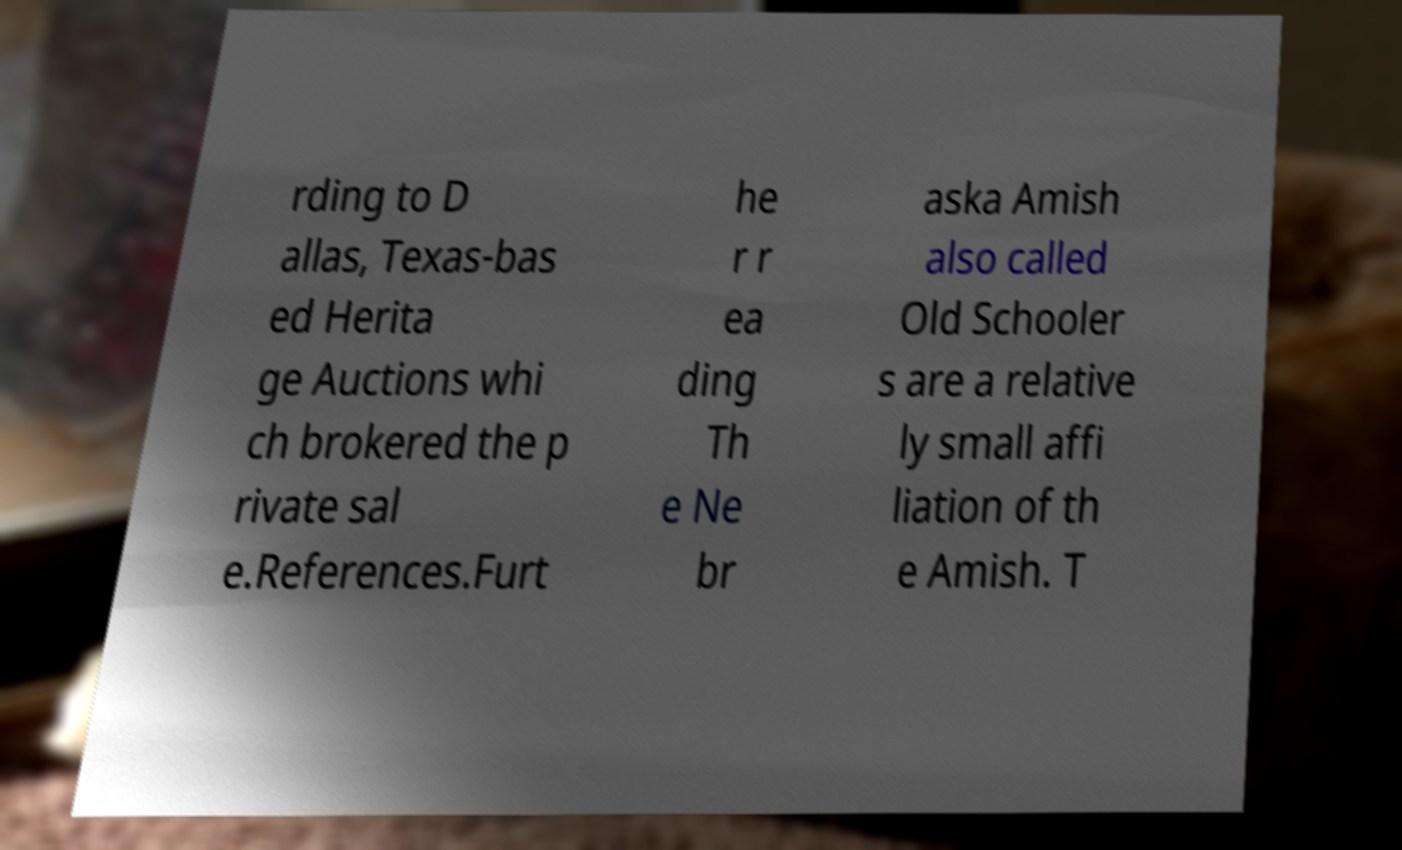There's text embedded in this image that I need extracted. Can you transcribe it verbatim? rding to D allas, Texas-bas ed Herita ge Auctions whi ch brokered the p rivate sal e.References.Furt he r r ea ding Th e Ne br aska Amish also called Old Schooler s are a relative ly small affi liation of th e Amish. T 